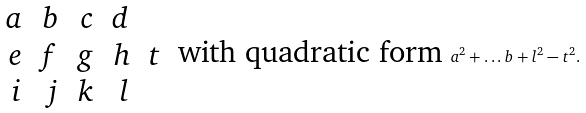<formula> <loc_0><loc_0><loc_500><loc_500>\begin{array} { r r r r r } a & b & c & d & \\ e & f & g & h & t \\ i & j & k & l & \end{array} \text { with quadratic form } a ^ { 2 } + \dots b + l ^ { 2 } - t ^ { 2 } .</formula> 